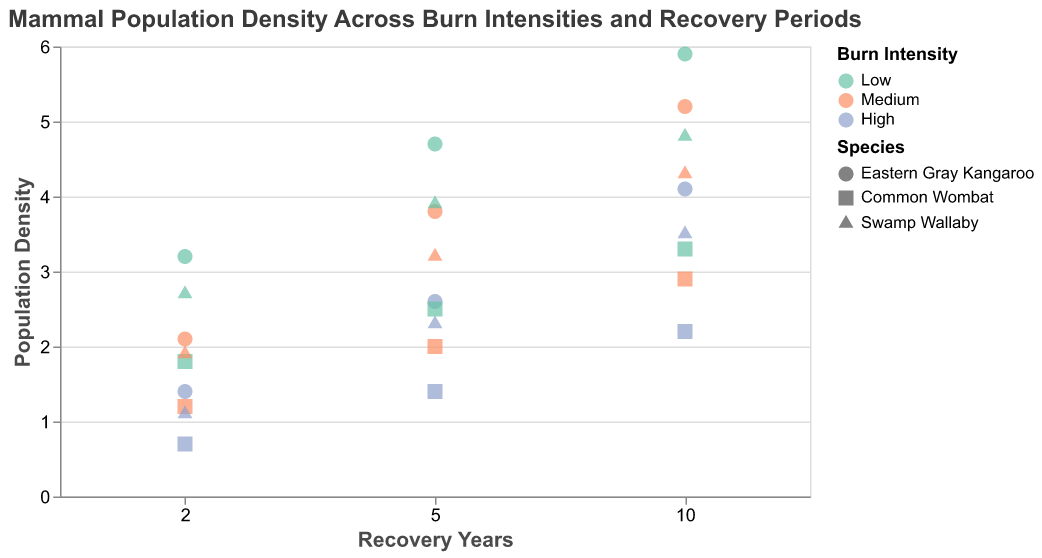What species has the highest population density at a burn intensity of High and 10 years of recovery? Look for the data points corresponding to a burn intensity of High and recovery years of 10. Compare the population densities of different species.
Answer: Eastern Gray Kangaroo How does the population density of the Common Wombat change from 2 to 10 years of recovery at Medium burn intensity? Check the population densities of the Common Wombat at 2, 5, and 10 years of recovery for Medium burn intensity and observe the changes.
Answer: Increases from 1.2 to 2.9 At 5 years of recovery, which burn intensity has the highest population density for the Swamp Wallaby? Look at the data points for the Swamp Wallaby at 5 years of recovery and compare the population densities across different burn intensities.
Answer: Low Which species shows the most significant increase in population density from 2 to 10 years under Low burn intensity? Compare the population densities of all species at 2, 5, and 10 years of recovery for Low burn intensity and identify the greatest increase.
Answer: Eastern Gray Kangaroo What's the average population density of all species at High burn intensity and 2 years of recovery? Identify the population densities of all species at High burn intensity and 2 years of recovery, then calculate the average. (1.4 + 0.7 + 1.1) / 3 = 3.2 / 3 = 1.1
Answer: 1.1 Which species has the most constant population density trend across different burn intensities after 10 years of recovery? Examine the population density data points for each species at 10 years of recovery and observe how constant each trend is across different burn intensities.
Answer: Swamp Wallaby Compare the population density of the Eastern Gray Kangaroo and the Common Wombat at Medium burn intensity after 5 years of recovery. Check the population densities of Eastern Gray Kangaroo and Common Wombat at Medium burn intensity and 5 years of recovery, then compare the values.
Answer: Eastern Gray Kangaroo: 3.8, Common Wombat: 2.0 Which burn intensity consistently leads to the lowest population density across all recovery periods for the Swamp Wallaby? Check the population density values of the Swamp Wallaby across all recovery periods for each burn intensity and identify the lowest trend.
Answer: High Determine the average population density of the Eastern Gray Kangaroo across all burn intensities and recovery periods. Add all population density values of the Eastern Gray Kangaroo and divide by the total number of data points (3.2+4.7+5.9+2.1+3.8+5.2+1.4+2.6+4.1) / 9 = 33.0 / 9 = 3.7
Answer: 3.7 